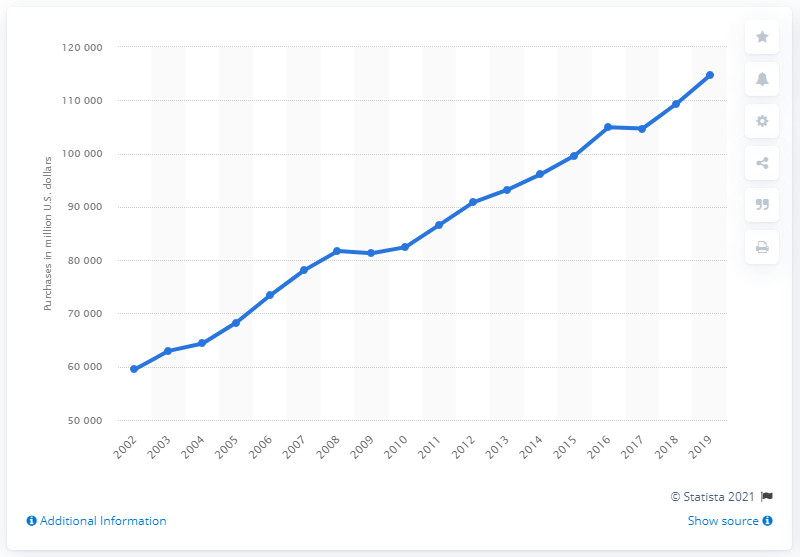Mention a couple of crucial points in this snapshot. In 2019, wholesalers in the United States purchased a total of 114,692 liters of beer, wine, and distilled alcoholic beverages. 